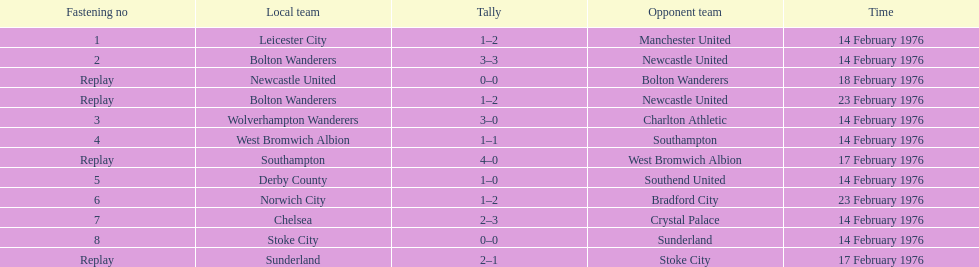Which teams played the same day as leicester city and manchester united? Bolton Wanderers, Newcastle United. 